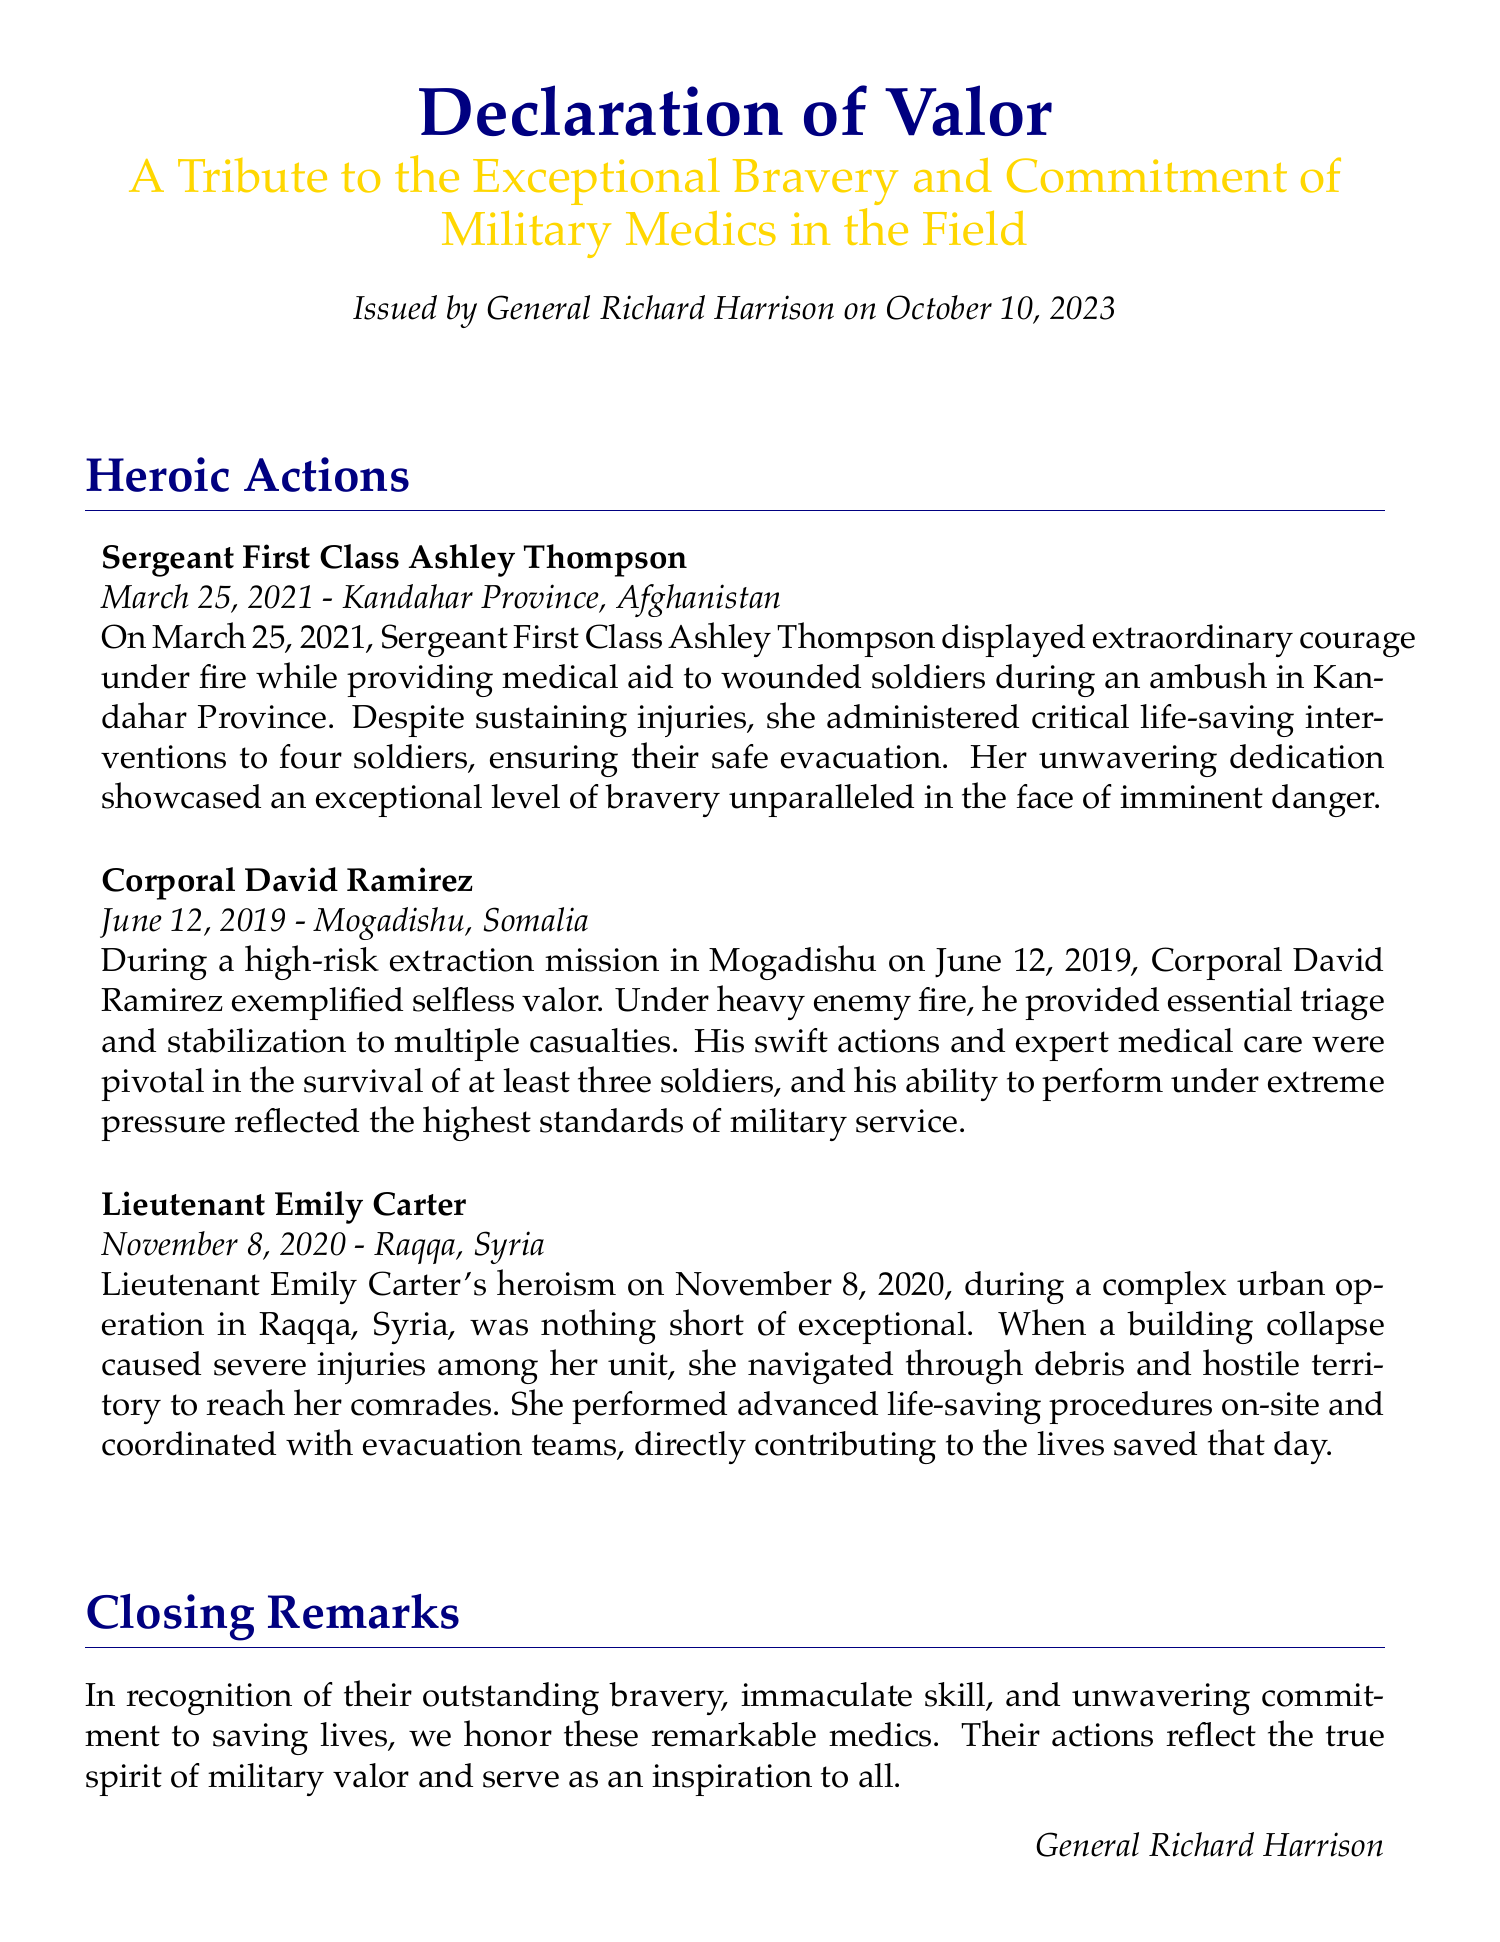What is the title of the document? The title of the document is prominently displayed at the top, detailing its purpose.
Answer: Declaration of Valor Who issued the declaration? The document specifies who issued it, providing a recognition of the medics' bravery.
Answer: General Richard Harrison On what date was the declaration issued? The date of issuance is mentioned clearly, giving context to the recognition.
Answer: October 10, 2023 Where did Sergeant First Class Ashley Thompson show her bravery? The document provides specific locations related to the accomplishments of the medics.
Answer: Kandahar Province, Afghanistan How many soldiers did Sergeant First Class Ashley Thompson save? In the description, the number of soldiers helped by Thompson during her act of bravery is indicated.
Answer: Four What significant action did Corporal David Ramirez perform? The document details significant contributions made by each medic, showcasing their valor.
Answer: Triage and stabilization What event caused injuries to Lieutenant Emily Carter's unit? The document outlines the circumstances under which medics rose to the occasion, including specific events.
Answer: Building collapse Which medic operated during a mission in Mogadishu, Somalia? The document includes names and locations linked to the heroic actions of the medics.
Answer: Corporal David Ramirez What does the declaration aim to honor? The closing remarks of the document summarize its intent and focus.
Answer: Outstanding bravery 